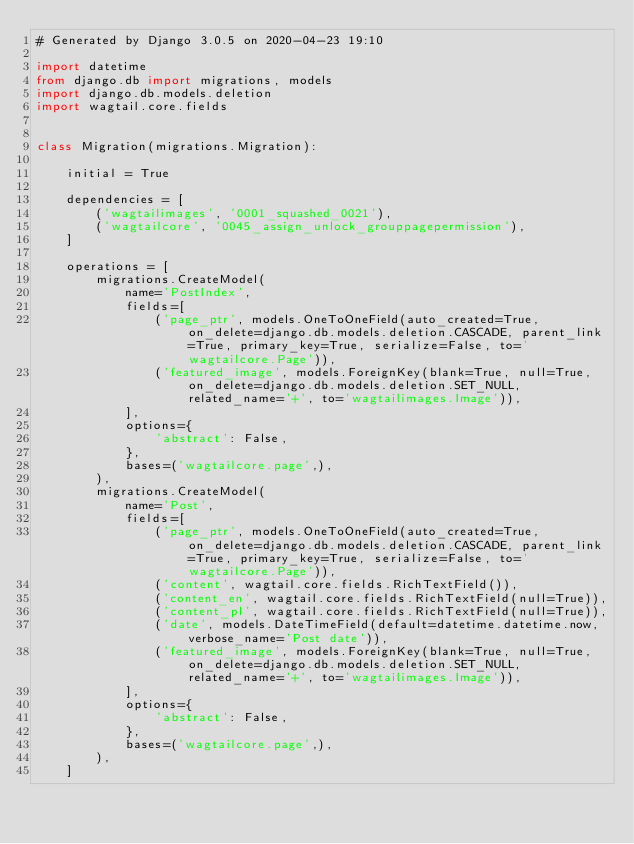Convert code to text. <code><loc_0><loc_0><loc_500><loc_500><_Python_># Generated by Django 3.0.5 on 2020-04-23 19:10

import datetime
from django.db import migrations, models
import django.db.models.deletion
import wagtail.core.fields


class Migration(migrations.Migration):

    initial = True

    dependencies = [
        ('wagtailimages', '0001_squashed_0021'),
        ('wagtailcore', '0045_assign_unlock_grouppagepermission'),
    ]

    operations = [
        migrations.CreateModel(
            name='PostIndex',
            fields=[
                ('page_ptr', models.OneToOneField(auto_created=True, on_delete=django.db.models.deletion.CASCADE, parent_link=True, primary_key=True, serialize=False, to='wagtailcore.Page')),
                ('featured_image', models.ForeignKey(blank=True, null=True, on_delete=django.db.models.deletion.SET_NULL, related_name='+', to='wagtailimages.Image')),
            ],
            options={
                'abstract': False,
            },
            bases=('wagtailcore.page',),
        ),
        migrations.CreateModel(
            name='Post',
            fields=[
                ('page_ptr', models.OneToOneField(auto_created=True, on_delete=django.db.models.deletion.CASCADE, parent_link=True, primary_key=True, serialize=False, to='wagtailcore.Page')),
                ('content', wagtail.core.fields.RichTextField()),
                ('content_en', wagtail.core.fields.RichTextField(null=True)),
                ('content_pl', wagtail.core.fields.RichTextField(null=True)),
                ('date', models.DateTimeField(default=datetime.datetime.now, verbose_name='Post date')),
                ('featured_image', models.ForeignKey(blank=True, null=True, on_delete=django.db.models.deletion.SET_NULL, related_name='+', to='wagtailimages.Image')),
            ],
            options={
                'abstract': False,
            },
            bases=('wagtailcore.page',),
        ),
    ]
</code> 